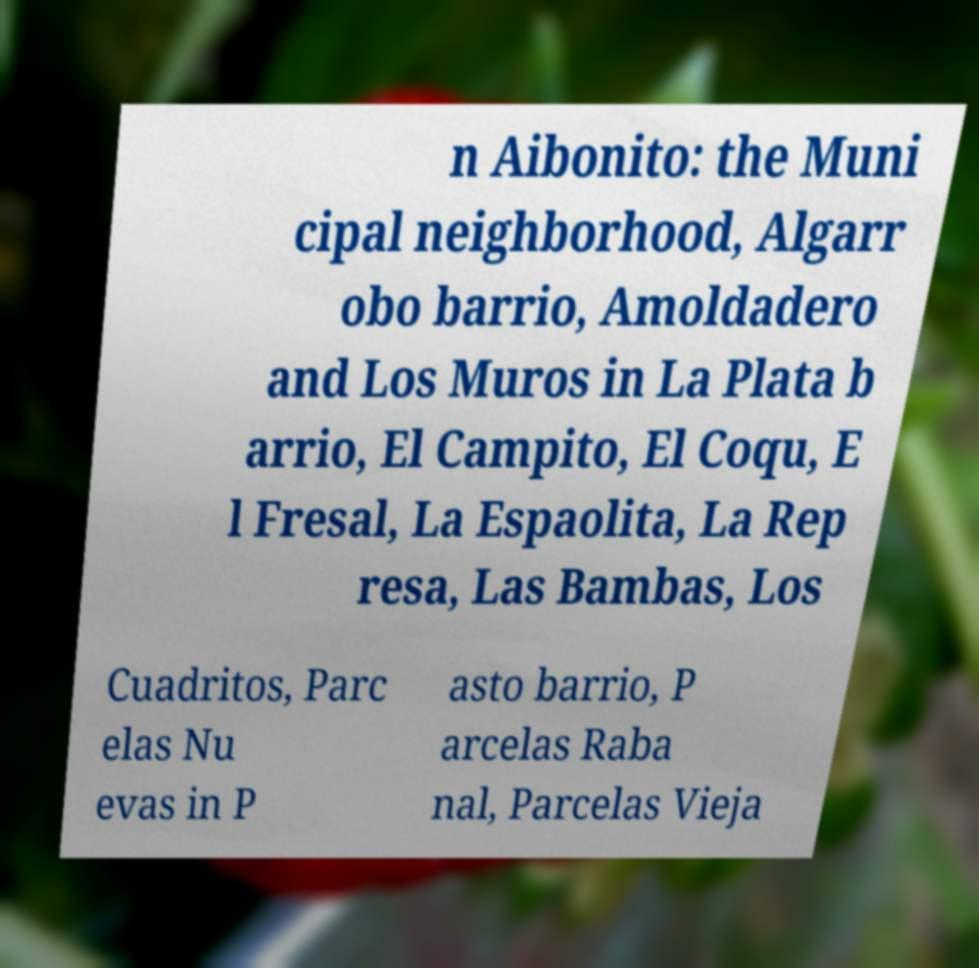Please read and relay the text visible in this image. What does it say? n Aibonito: the Muni cipal neighborhood, Algarr obo barrio, Amoldadero and Los Muros in La Plata b arrio, El Campito, El Coqu, E l Fresal, La Espaolita, La Rep resa, Las Bambas, Los Cuadritos, Parc elas Nu evas in P asto barrio, P arcelas Raba nal, Parcelas Vieja 